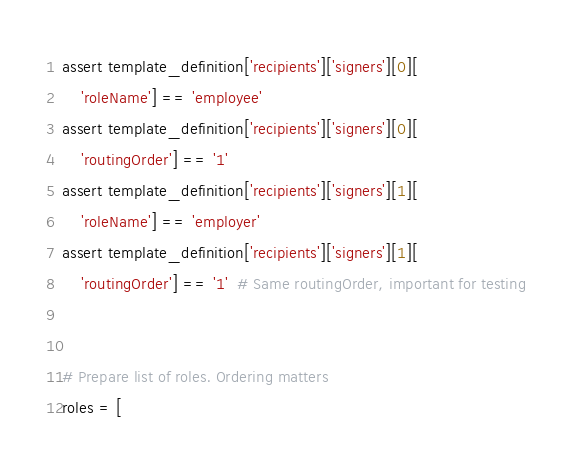<code> <loc_0><loc_0><loc_500><loc_500><_Python_>assert template_definition['recipients']['signers'][0][
    'roleName'] == 'employee'
assert template_definition['recipients']['signers'][0][
    'routingOrder'] == '1'
assert template_definition['recipients']['signers'][1][
    'roleName'] == 'employer'
assert template_definition['recipients']['signers'][1][
    'routingOrder'] == '1'  # Same routingOrder, important for testing


# Prepare list of roles. Ordering matters
roles = [</code> 